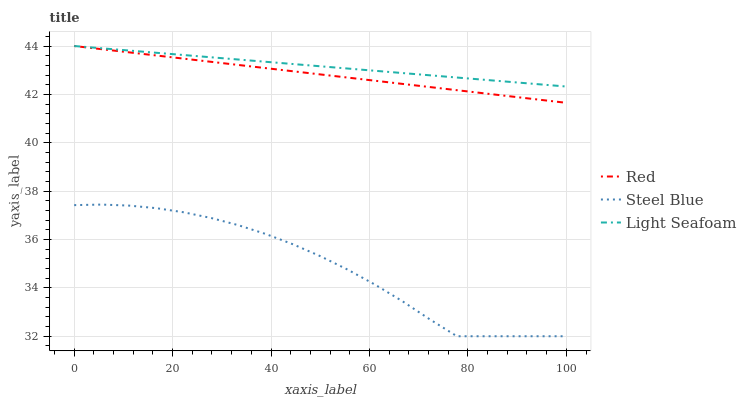Does Steel Blue have the minimum area under the curve?
Answer yes or no. Yes. Does Light Seafoam have the maximum area under the curve?
Answer yes or no. Yes. Does Red have the minimum area under the curve?
Answer yes or no. No. Does Red have the maximum area under the curve?
Answer yes or no. No. Is Light Seafoam the smoothest?
Answer yes or no. Yes. Is Steel Blue the roughest?
Answer yes or no. Yes. Is Red the smoothest?
Answer yes or no. No. Is Red the roughest?
Answer yes or no. No. Does Red have the lowest value?
Answer yes or no. No. Does Steel Blue have the highest value?
Answer yes or no. No. Is Steel Blue less than Light Seafoam?
Answer yes or no. Yes. Is Red greater than Steel Blue?
Answer yes or no. Yes. Does Steel Blue intersect Light Seafoam?
Answer yes or no. No. 